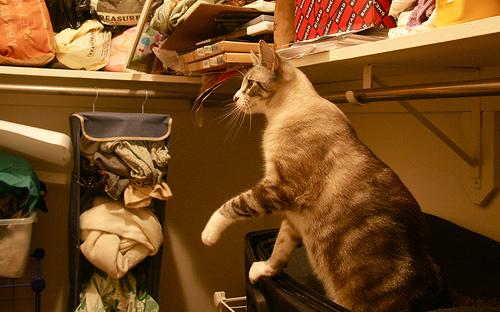Is there more than one animal?
Write a very short answer. No. Is this animal a pet?
Write a very short answer. Yes. What type is it?
Give a very brief answer. Cat. 